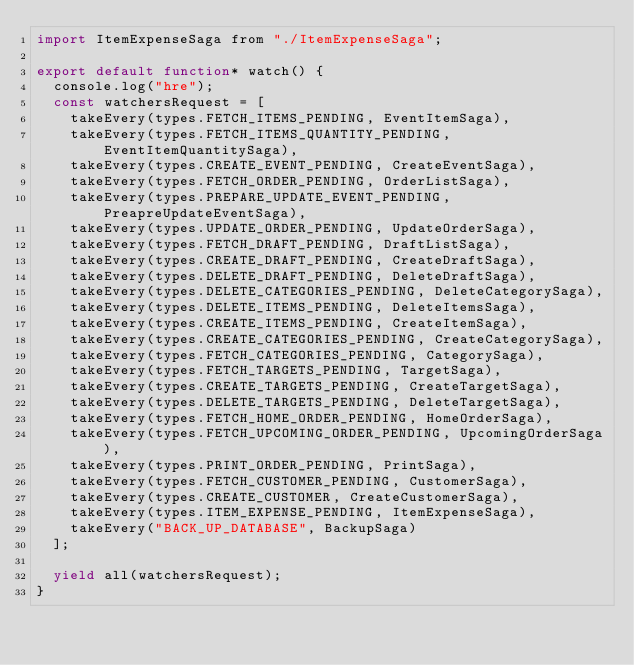Convert code to text. <code><loc_0><loc_0><loc_500><loc_500><_JavaScript_>import ItemExpenseSaga from "./ItemExpenseSaga";

export default function* watch() {
  console.log("hre");
  const watchersRequest = [
    takeEvery(types.FETCH_ITEMS_PENDING, EventItemSaga),
    takeEvery(types.FETCH_ITEMS_QUANTITY_PENDING, EventItemQuantitySaga),
    takeEvery(types.CREATE_EVENT_PENDING, CreateEventSaga),
    takeEvery(types.FETCH_ORDER_PENDING, OrderListSaga),
    takeEvery(types.PREPARE_UPDATE_EVENT_PENDING, PreapreUpdateEventSaga),
    takeEvery(types.UPDATE_ORDER_PENDING, UpdateOrderSaga),
    takeEvery(types.FETCH_DRAFT_PENDING, DraftListSaga),
    takeEvery(types.CREATE_DRAFT_PENDING, CreateDraftSaga),
    takeEvery(types.DELETE_DRAFT_PENDING, DeleteDraftSaga),
    takeEvery(types.DELETE_CATEGORIES_PENDING, DeleteCategorySaga),
    takeEvery(types.DELETE_ITEMS_PENDING, DeleteItemsSaga),
    takeEvery(types.CREATE_ITEMS_PENDING, CreateItemSaga),
    takeEvery(types.CREATE_CATEGORIES_PENDING, CreateCategorySaga),
    takeEvery(types.FETCH_CATEGORIES_PENDING, CategorySaga),
    takeEvery(types.FETCH_TARGETS_PENDING, TargetSaga),
    takeEvery(types.CREATE_TARGETS_PENDING, CreateTargetSaga),
    takeEvery(types.DELETE_TARGETS_PENDING, DeleteTargetSaga),
    takeEvery(types.FETCH_HOME_ORDER_PENDING, HomeOrderSaga),
    takeEvery(types.FETCH_UPCOMING_ORDER_PENDING, UpcomingOrderSaga),
    takeEvery(types.PRINT_ORDER_PENDING, PrintSaga),
    takeEvery(types.FETCH_CUSTOMER_PENDING, CustomerSaga),
    takeEvery(types.CREATE_CUSTOMER, CreateCustomerSaga),
    takeEvery(types.ITEM_EXPENSE_PENDING, ItemExpenseSaga),
    takeEvery("BACK_UP_DATABASE", BackupSaga)
  ];

  yield all(watchersRequest);
}
</code> 